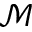Convert formula to latex. <formula><loc_0><loc_0><loc_500><loc_500>\mathcal { M }</formula> 